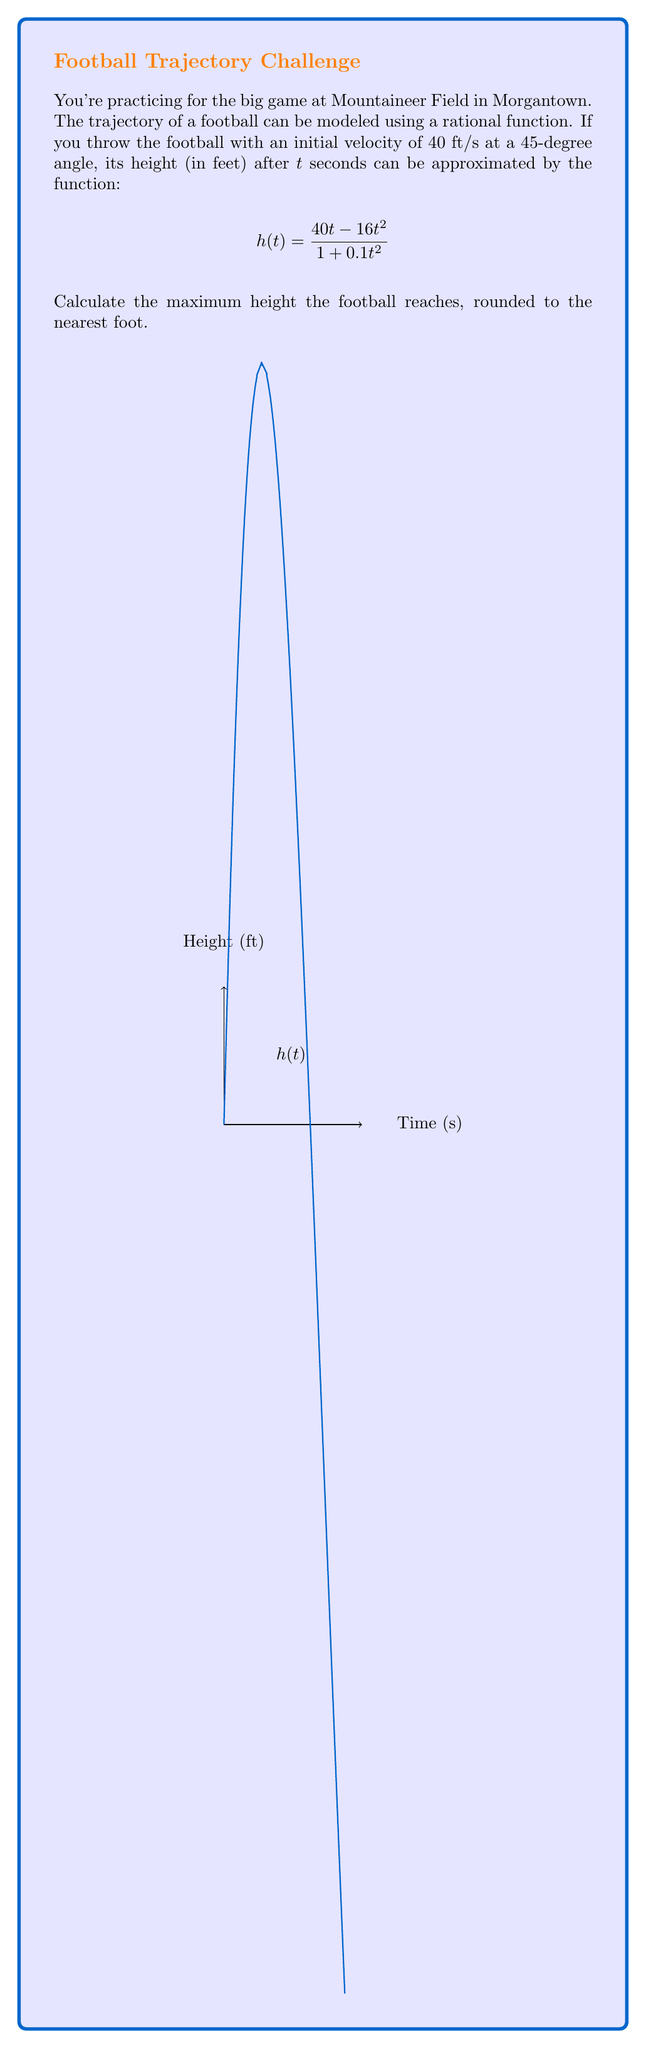Teach me how to tackle this problem. Let's approach this step-by-step:

1) To find the maximum height, we need to find the peak of the function $h(t)$. This occurs where the derivative $h'(t) = 0$.

2) Let's find $h'(t)$ using the quotient rule:

   $$h'(t) = \frac{(1+0.1t^2)(40-32t) - (40t-16t^2)(0.2t)}{(1+0.1t^2)^2}$$

3) Simplify:

   $$h'(t) = \frac{40+4t^2-32t-32t^3+8t^3-0.8t^3}{(1+0.1t^2)^2}$$
   
   $$h'(t) = \frac{40+4t^2-32t-24.8t^3}{(1+0.1t^2)^2}$$

4) Set $h'(t) = 0$ and solve for t:

   $$40+4t^2-32t-24.8t^3 = 0$$

5) This is a cubic equation and solving it analytically is complex. We can use a graphing calculator or numerical methods to find that the solution is approximately $t \approx 1.25$ seconds.

6) Now, let's plug this value back into our original function:

   $$h(1.25) = \frac{40(1.25) - 16(1.25)^2}{1 + 0.1(1.25)^2}$$

7) Calculate:

   $$h(1.25) = \frac{50 - 25}{1 + 0.15625} \approx 21.62$$

8) Rounding to the nearest foot:

   $$h(1.25) \approx 22 \text{ feet}$$

Therefore, the maximum height the football reaches is approximately 22 feet.
Answer: 22 feet 